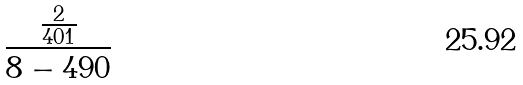Convert formula to latex. <formula><loc_0><loc_0><loc_500><loc_500>\frac { \frac { 2 } { 4 0 1 } } { 8 - 4 9 0 }</formula> 